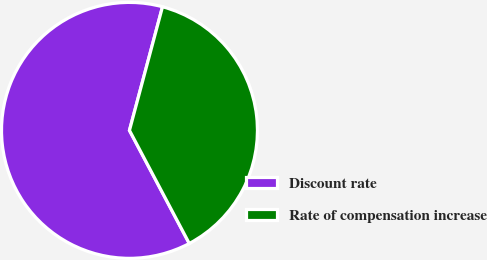Convert chart to OTSL. <chart><loc_0><loc_0><loc_500><loc_500><pie_chart><fcel>Discount rate<fcel>Rate of compensation increase<nl><fcel>61.9%<fcel>38.1%<nl></chart> 